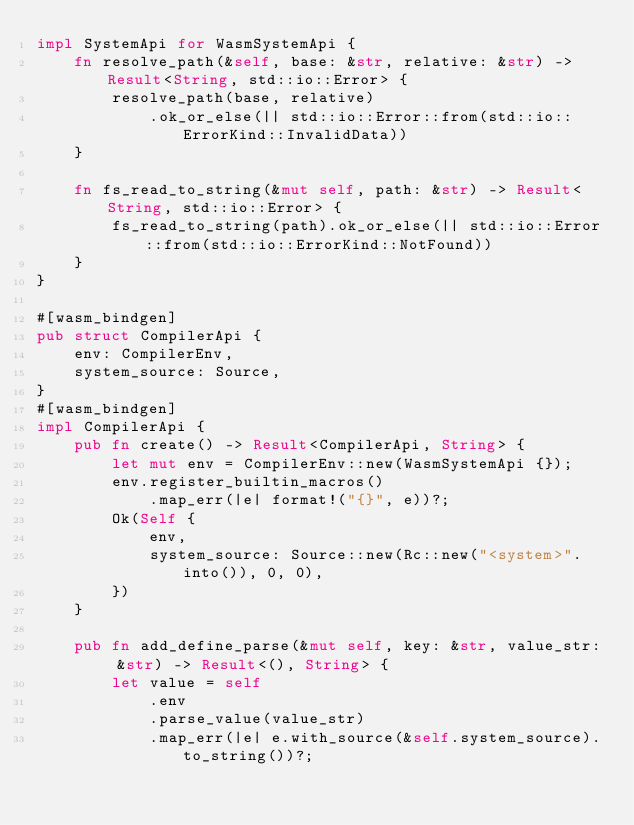<code> <loc_0><loc_0><loc_500><loc_500><_Rust_>impl SystemApi for WasmSystemApi {
    fn resolve_path(&self, base: &str, relative: &str) -> Result<String, std::io::Error> {
        resolve_path(base, relative)
            .ok_or_else(|| std::io::Error::from(std::io::ErrorKind::InvalidData))
    }

    fn fs_read_to_string(&mut self, path: &str) -> Result<String, std::io::Error> {
        fs_read_to_string(path).ok_or_else(|| std::io::Error::from(std::io::ErrorKind::NotFound))
    }
}

#[wasm_bindgen]
pub struct CompilerApi {
    env: CompilerEnv,
    system_source: Source,
}
#[wasm_bindgen]
impl CompilerApi {
    pub fn create() -> Result<CompilerApi, String> {
        let mut env = CompilerEnv::new(WasmSystemApi {});
        env.register_builtin_macros()
            .map_err(|e| format!("{}", e))?;
        Ok(Self {
            env,
            system_source: Source::new(Rc::new("<system>".into()), 0, 0),
        })
    }

    pub fn add_define_parse(&mut self, key: &str, value_str: &str) -> Result<(), String> {
        let value = self
            .env
            .parse_value(value_str)
            .map_err(|e| e.with_source(&self.system_source).to_string())?;</code> 